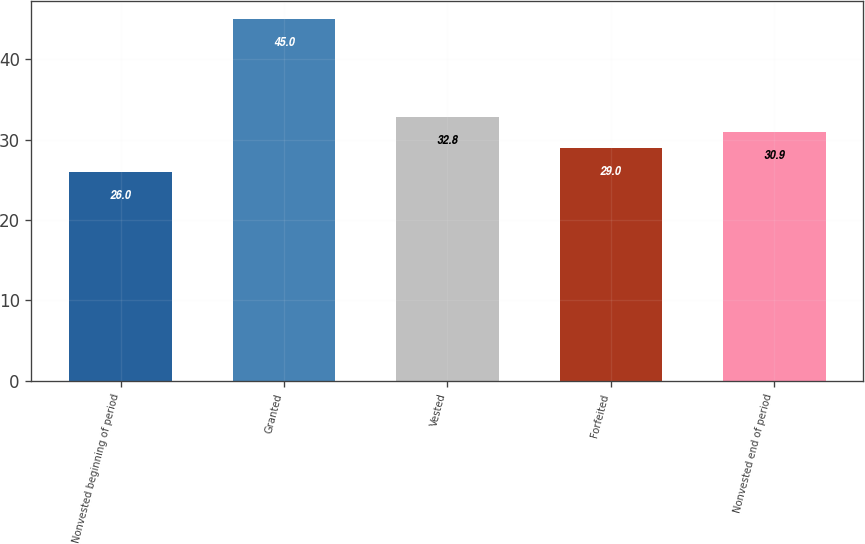<chart> <loc_0><loc_0><loc_500><loc_500><bar_chart><fcel>Nonvested beginning of period<fcel>Granted<fcel>Vested<fcel>Forfeited<fcel>Nonvested end of period<nl><fcel>26<fcel>45<fcel>32.8<fcel>29<fcel>30.9<nl></chart> 